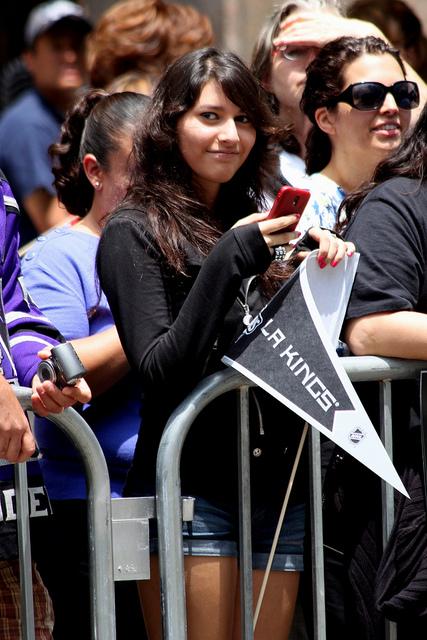What does the flag say?
Give a very brief answer. La kings. Where do the LA Kings play from?
Give a very brief answer. Los angeles. What color is the cell phone?
Write a very short answer. Red. 